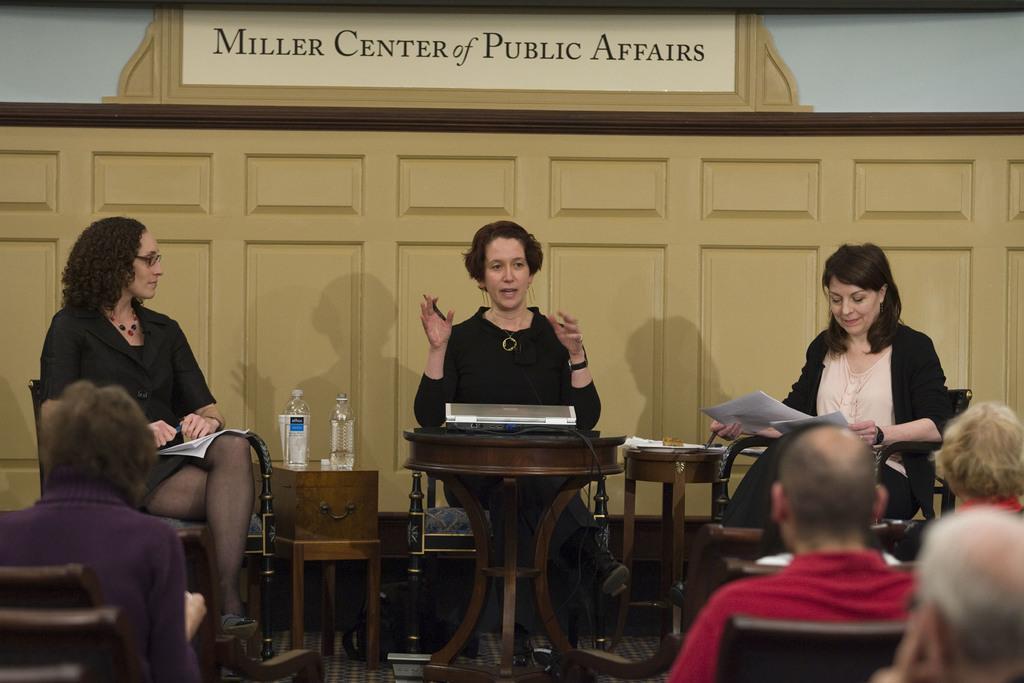How would you summarize this image in a sentence or two? There are three women sitting on the chair. Here is a small table with a water bottles on it. This looks like a name board at the background. These are the audience sitting on the chairs. 